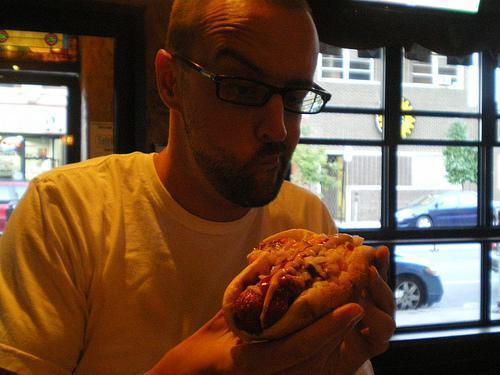How many people are shown?
Give a very brief answer. 1. 